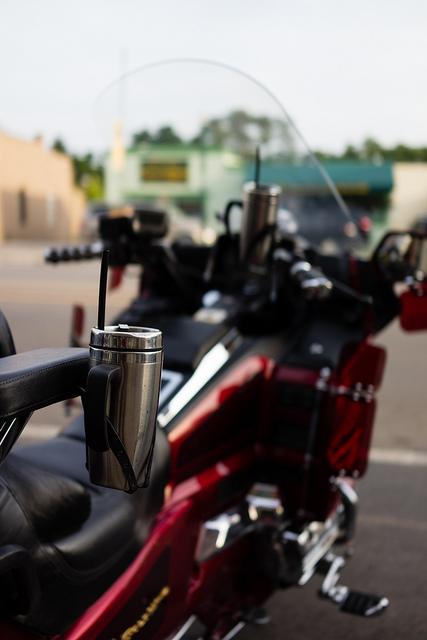What color is the bike?
Keep it brief. Red. Is the bike moving?
Write a very short answer. No. What metal is the cup constructed of?
Quick response, please. Aluminum. 